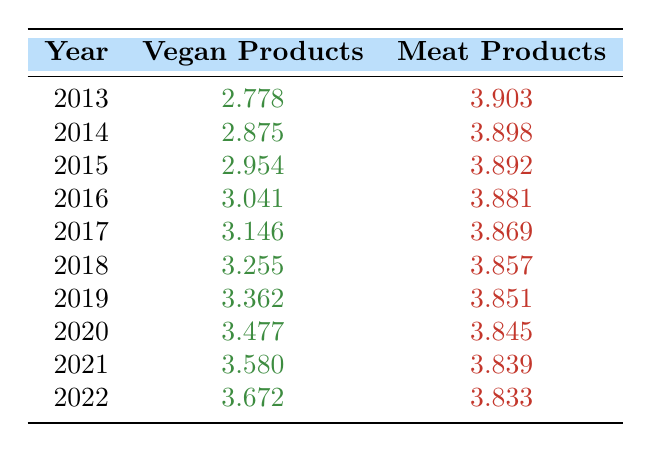What were the vegan product sales in 2020? From the table, the value for vegan product sales in 2020 is clearly listed as 3.477.
Answer: 3.477 What year had the highest meat product sales? By reviewing each row in the meat products column, we see that 2013 has the highest value of 3.903.
Answer: 2013 Which year had the lowest vegan product sales? Looking through the vegan products column, we find that 2013 had the lowest sales at 2.778.
Answer: 2013 What is the difference in sales between vegan and meat products in 2022? In 2022, vegan product sales were 3.672 and meat product sales were 3.833. The difference can be calculated by subtracting the vegan sales from the meat sales: 3.833 - 3.672 = 0.161.
Answer: 0.161 Is it true that vegan products consistently increased in sales every year from 2013 to 2022? Checking the vegan products column, we observe that each year from 2013 to 2022 shows higher sales than the previous year, confirming this as true.
Answer: Yes What was the average vegan product sales from 2013 to 2022? To calculate the average, we sum all the sales values from 2013 (2.778) to 2022 (3.672), giving us a total of approximately 27.571. There are 10 years, so the average would be 27.571 divided by 10, resulting in approximately 2.7571.
Answer: 2.7571 In which year did vegan products surpass 3.0 in sales? By examining the vegan product sales values, we see that sales surpassed 3.0 for the first time in 2016, with a value of 3.041.
Answer: 2016 What trend can be observed in vegan product sales from 2013 to 2022? By looking at the numbers, the values in the vegan column show a steady upwards trend, indicating a consistent increase in sales each year.
Answer: Steady increase What is the total vegan product sales for the years 2019 and 2020? For these years, the vegan product sales are 3.362 for 2019 and 3.477 for 2020. Adding these together gives 3.362 + 3.477 = 6.839.
Answer: 6.839 